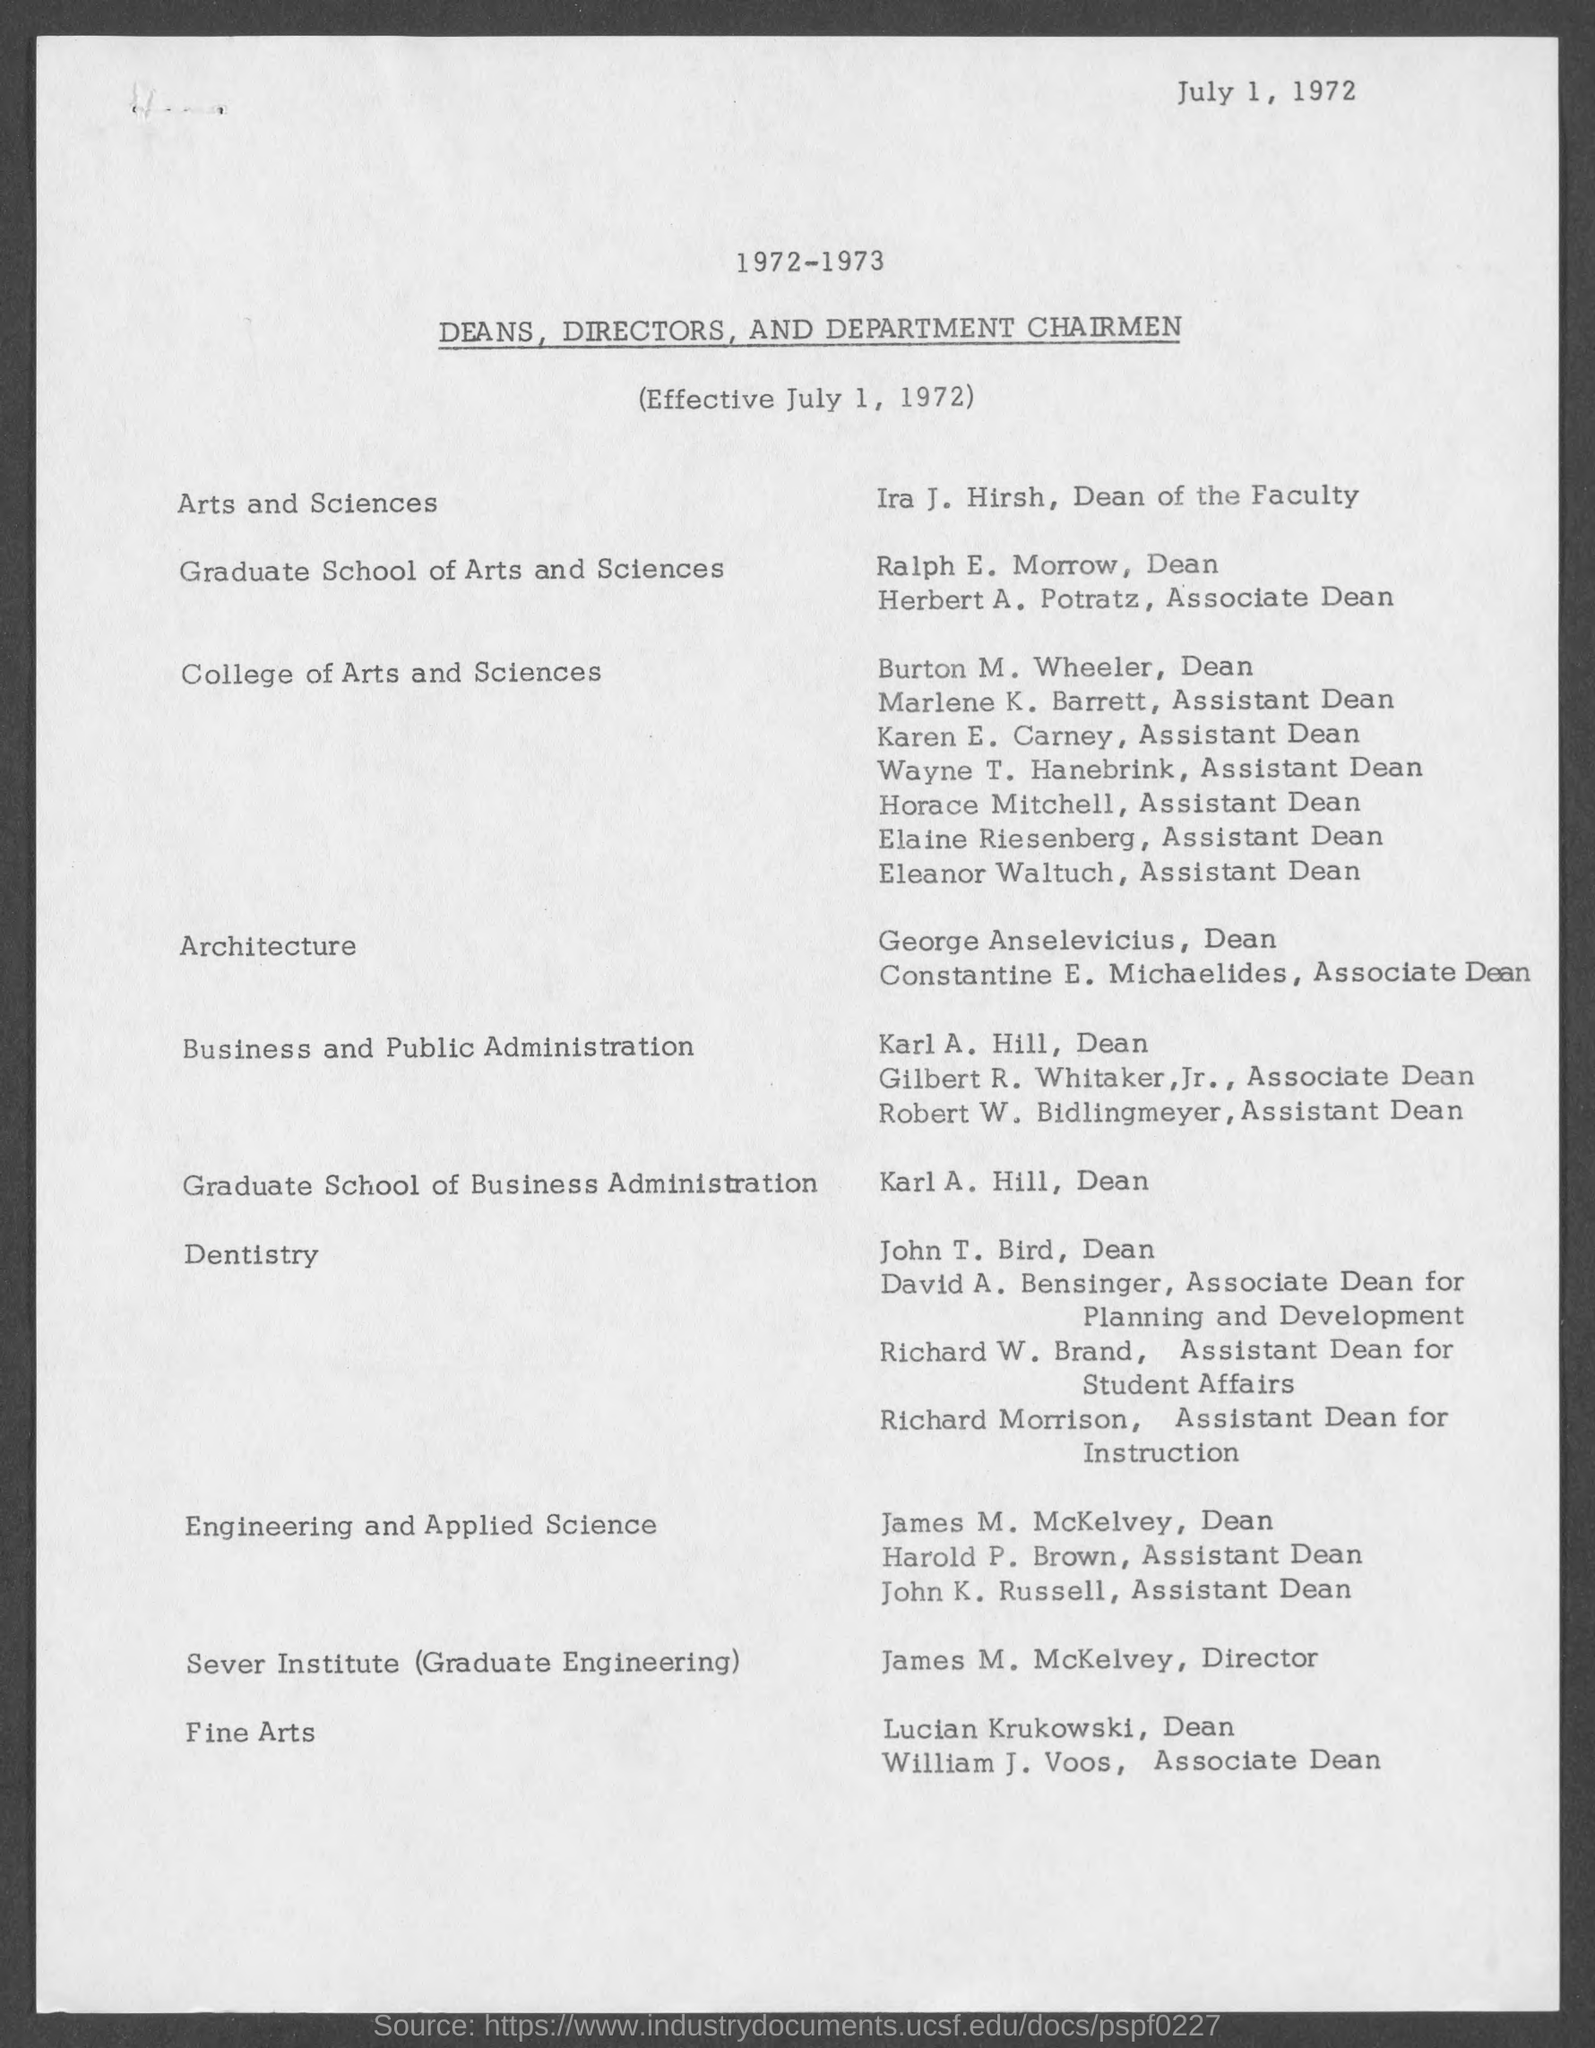What is the position of ira j. hirsh?
Provide a succinct answer. Dean of the faculty. What is the position of ralph e. morrow ?
Give a very brief answer. Dean. What is the position of herbert a. potratz ?
Your answer should be very brief. Associate Dean. What is the position of burton m. wheeler ?
Offer a terse response. Dean. What is the position of marlene k. barrett ?
Your answer should be compact. Assistant Dean. What is the position of karen e. carney?
Provide a short and direct response. Assistant dean. What is the position of wayne t. hanebrink ?
Provide a short and direct response. Assistant dean. What is the position of horace mitchell ?
Offer a terse response. Assistant Dean. What is the position of elaine riesenberg ?
Offer a terse response. Assistant dean. What is the position of eleanor waltuch ?
Give a very brief answer. Assistant Dean. 